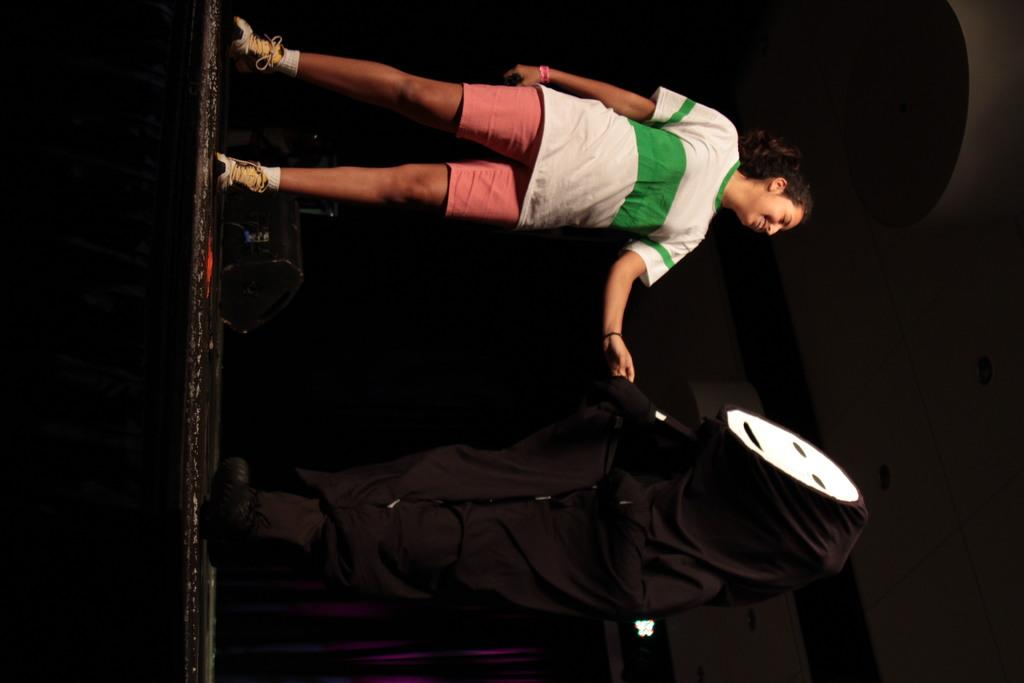Who is present in the image? There is a woman in the image. What is the woman doing in the image? The woman is standing and smiling. What can be seen beside the woman in the image? There is an object covered in a black dress beside the woman. What type of steam is coming from the woman's head in the image? There is no steam coming from the woman's head in the image. What is the woman using the hammer for in the image? There is no hammer present in the image. Can you see the moon in the background of the image? The moon is not visible in the image. 